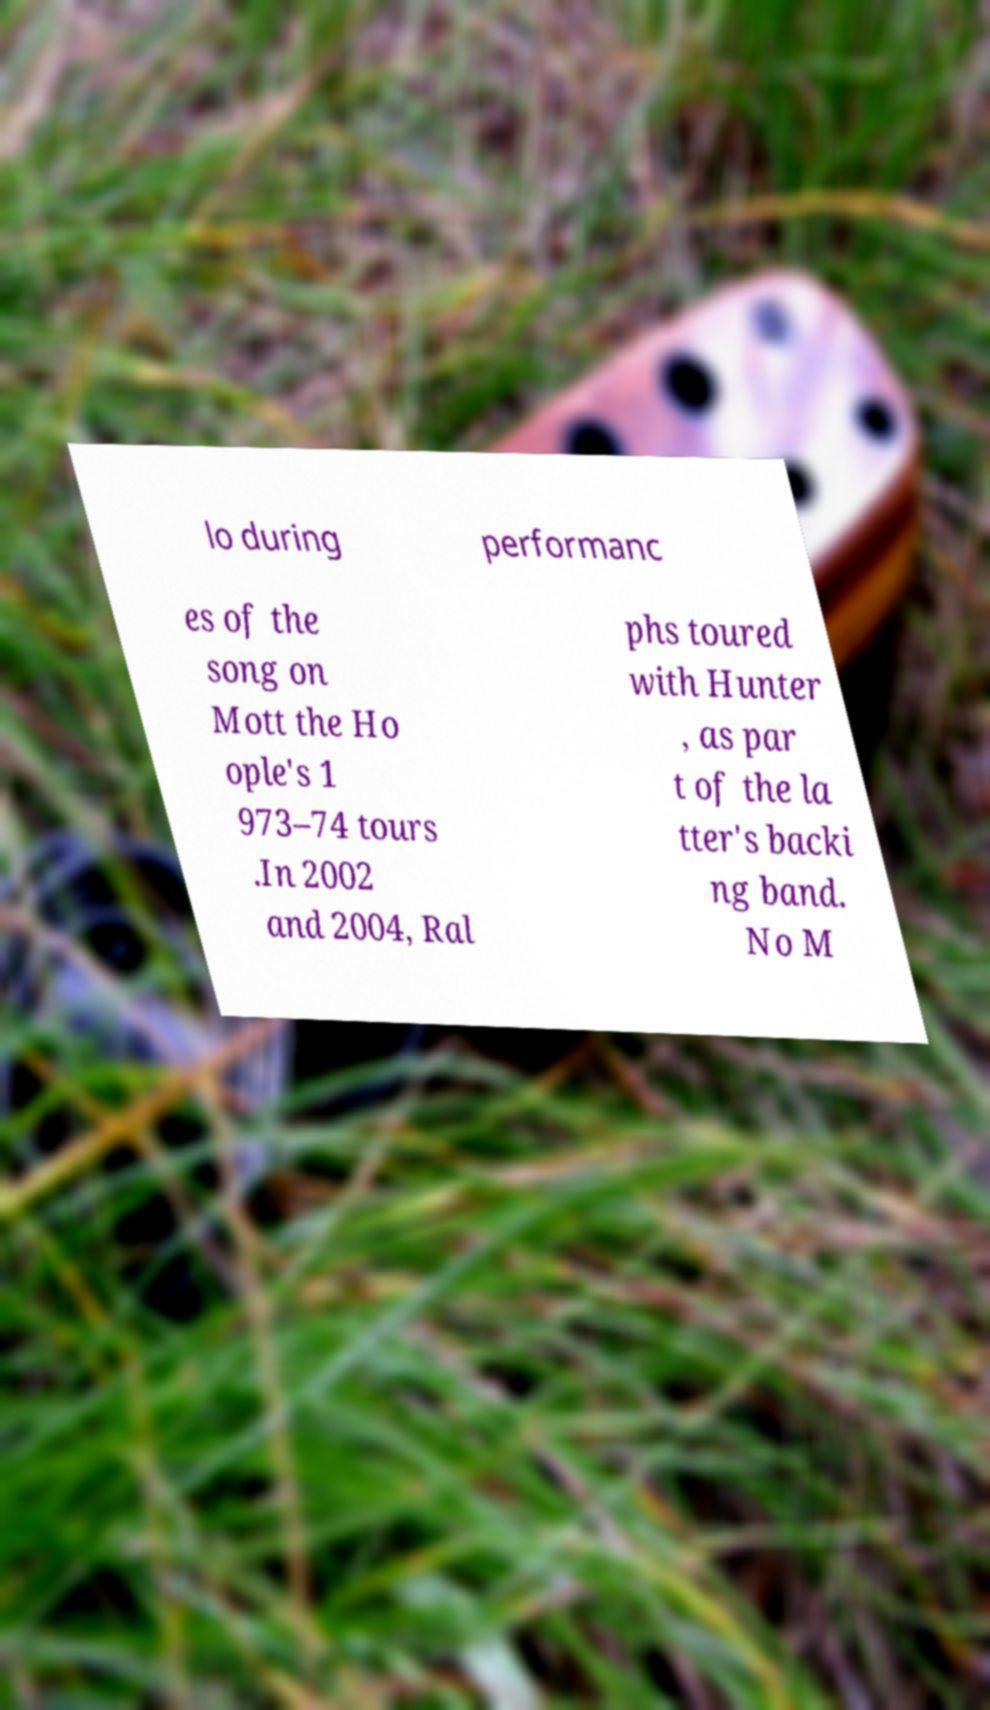Can you accurately transcribe the text from the provided image for me? lo during performanc es of the song on Mott the Ho ople's 1 973–74 tours .In 2002 and 2004, Ral phs toured with Hunter , as par t of the la tter's backi ng band. No M 